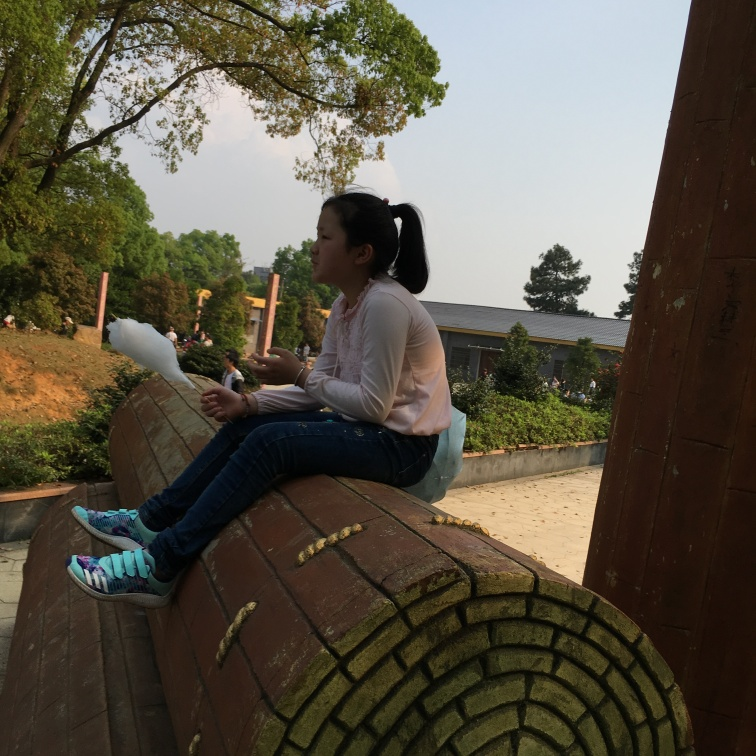Are there any quality issues with this image? Yes, there are a few quality issues with the image. Firstly, it appears to be slightly overexposed, causing some loss of detail in the brighter areas. Furthermore, the focus is not sharp, particularly around the subject's face and upper body, which detracts from the clarity. Lastly, there is a noticeable tilt to the right, which could be corrected to improve the composition. 